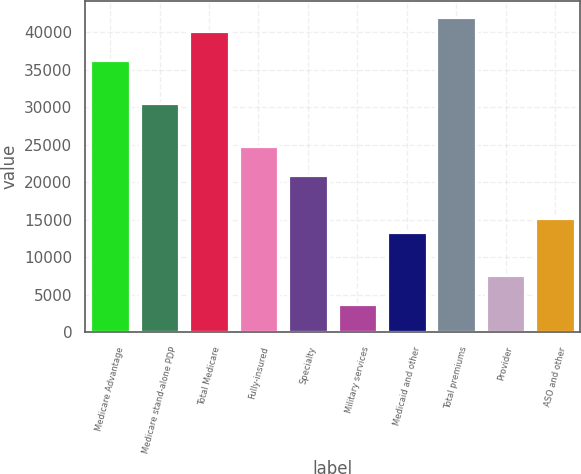Convert chart. <chart><loc_0><loc_0><loc_500><loc_500><bar_chart><fcel>Medicare Advantage<fcel>Medicare stand-alone PDP<fcel>Total Medicare<fcel>Fully-insured<fcel>Specialty<fcel>Military services<fcel>Medicaid and other<fcel>Total premiums<fcel>Provider<fcel>ASO and other<nl><fcel>36371<fcel>30628.3<fcel>40199.4<fcel>24885.6<fcel>21057.2<fcel>3829.22<fcel>13400.3<fcel>42113.6<fcel>7657.66<fcel>15314.5<nl></chart> 